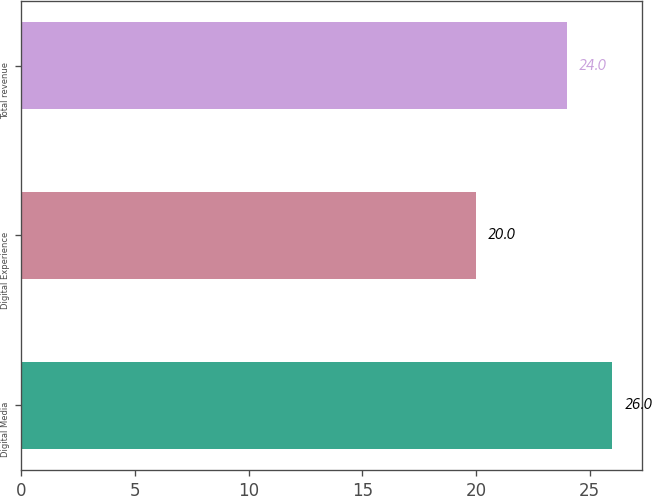Convert chart to OTSL. <chart><loc_0><loc_0><loc_500><loc_500><bar_chart><fcel>Digital Media<fcel>Digital Experience<fcel>Total revenue<nl><fcel>26<fcel>20<fcel>24<nl></chart> 